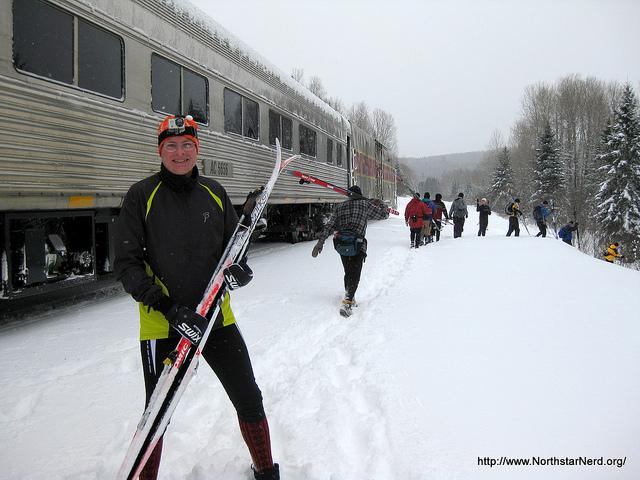How did these skiers get to this location?

Choices:
A) ski lift
B) train
C) uber
D) bus train 